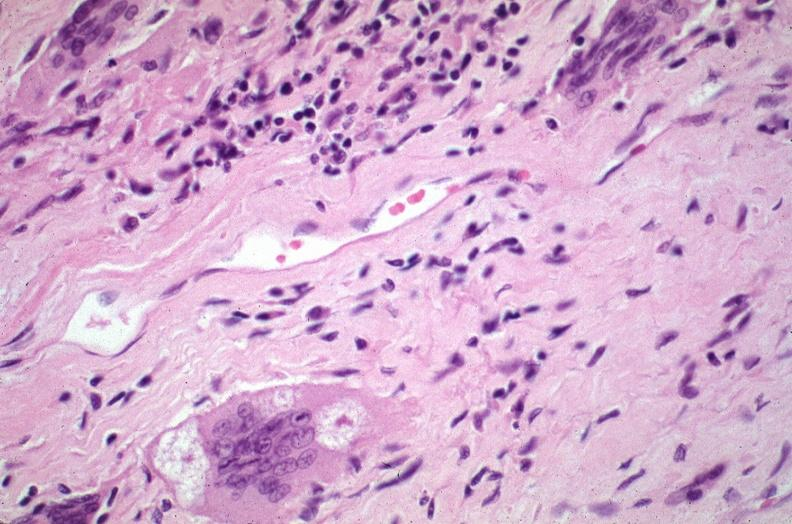how does this image show lung, sarcoidosis, multinucleated giant cells?
Answer the question using a single word or phrase. With asteroid bodies 